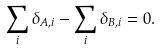<formula> <loc_0><loc_0><loc_500><loc_500>\sum _ { i } \delta _ { A , i } - \sum _ { i } \delta _ { B , i } = 0 .</formula> 